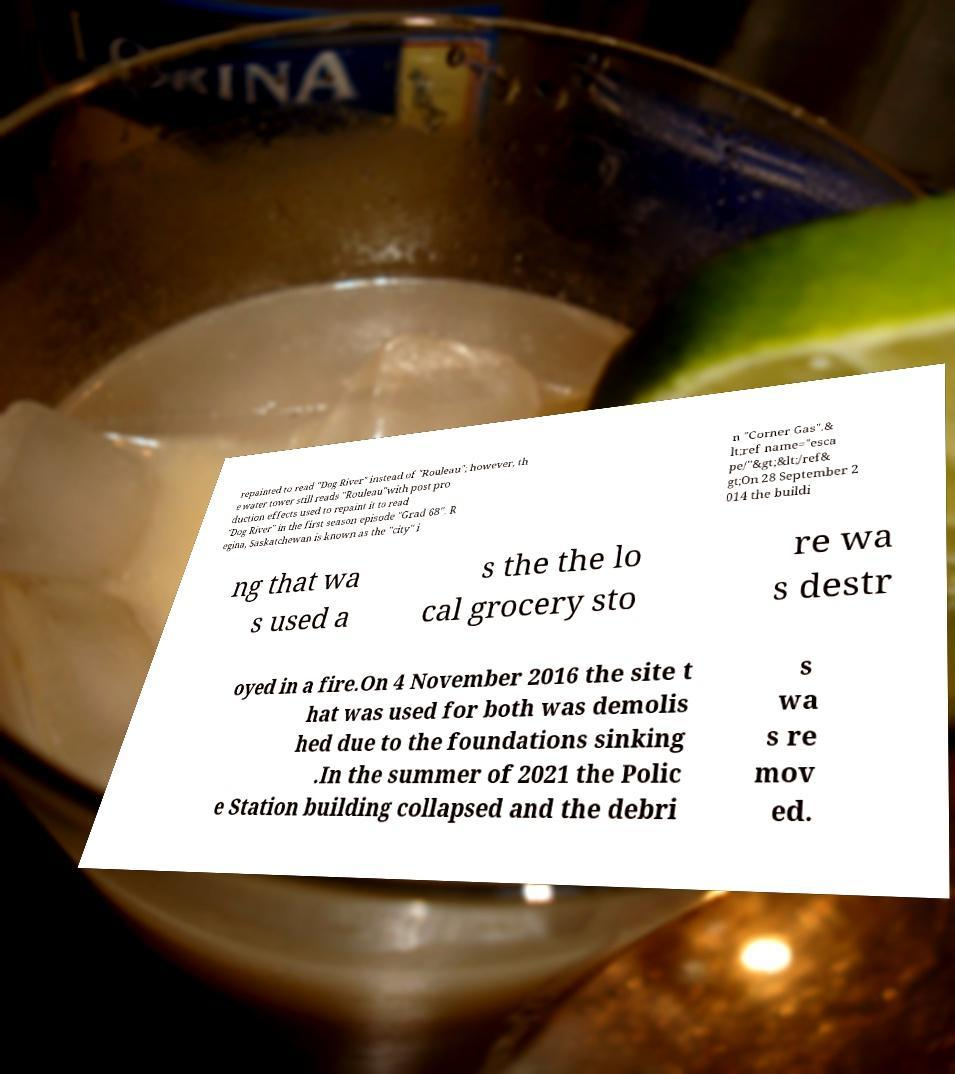Can you read and provide the text displayed in the image?This photo seems to have some interesting text. Can you extract and type it out for me? repainted to read "Dog River" instead of "Rouleau"; however, th e water tower still reads "Rouleau"with post pro duction effects used to repaint it to read "Dog River" in the first season episode "Grad 68". R egina, Saskatchewan is known as the "city" i n "Corner Gas".& lt;ref name="esca pe/"&gt;&lt;/ref& gt;On 28 September 2 014 the buildi ng that wa s used a s the the lo cal grocery sto re wa s destr oyed in a fire.On 4 November 2016 the site t hat was used for both was demolis hed due to the foundations sinking .In the summer of 2021 the Polic e Station building collapsed and the debri s wa s re mov ed. 